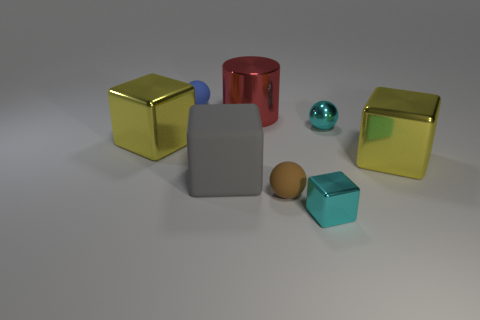Add 1 purple rubber blocks. How many objects exist? 9 Subtract all cylinders. How many objects are left? 7 Subtract 2 yellow cubes. How many objects are left? 6 Subtract all cyan blocks. Subtract all big objects. How many objects are left? 3 Add 5 matte objects. How many matte objects are left? 8 Add 7 large yellow objects. How many large yellow objects exist? 9 